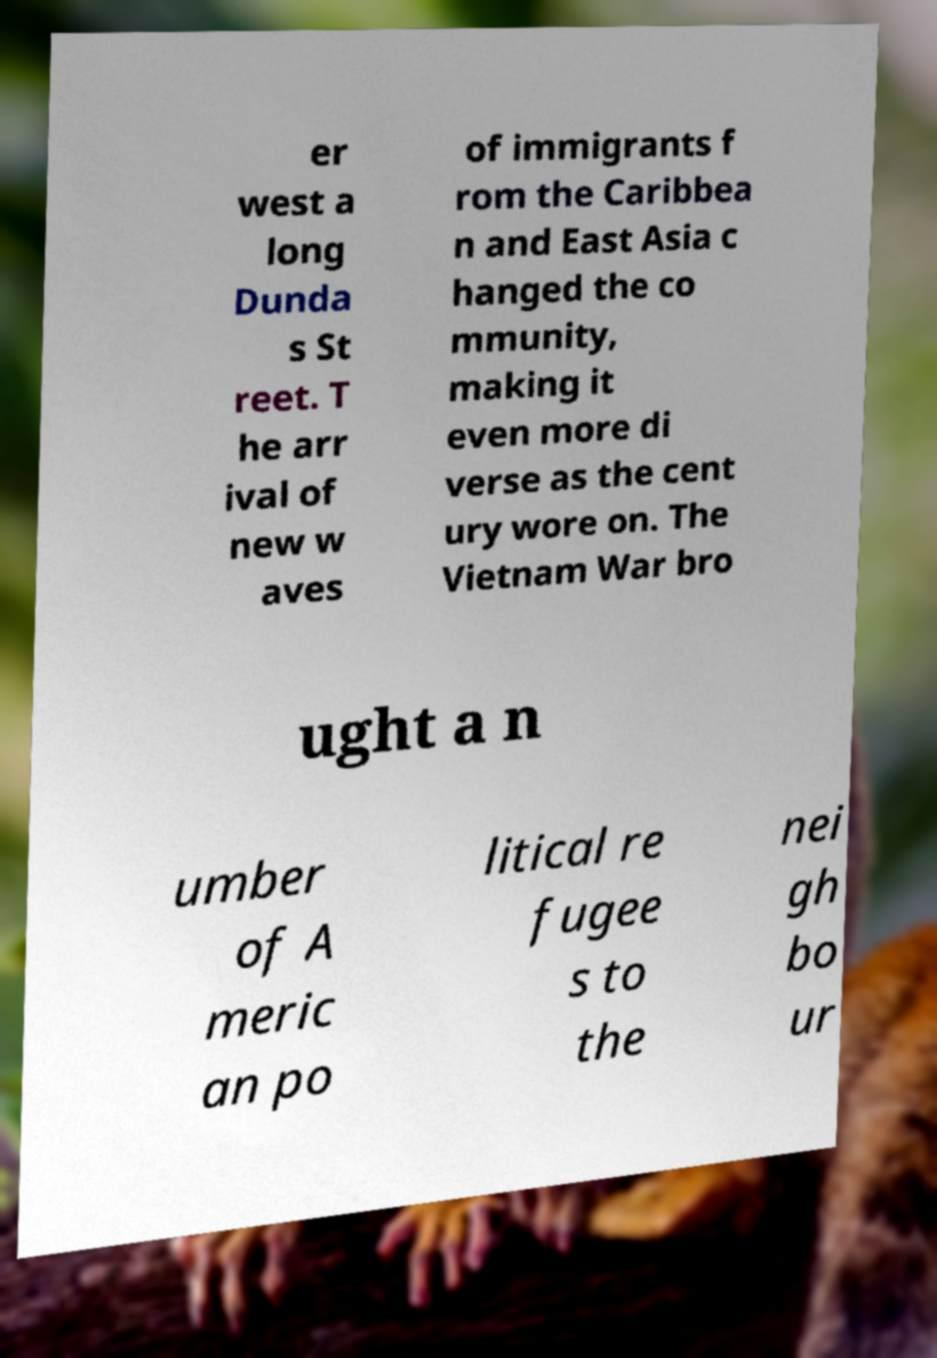Please identify and transcribe the text found in this image. er west a long Dunda s St reet. T he arr ival of new w aves of immigrants f rom the Caribbea n and East Asia c hanged the co mmunity, making it even more di verse as the cent ury wore on. The Vietnam War bro ught a n umber of A meric an po litical re fugee s to the nei gh bo ur 